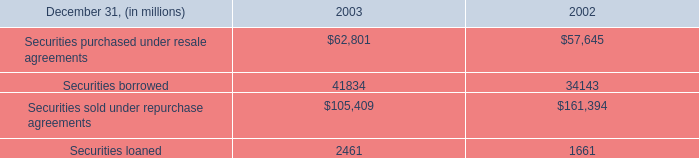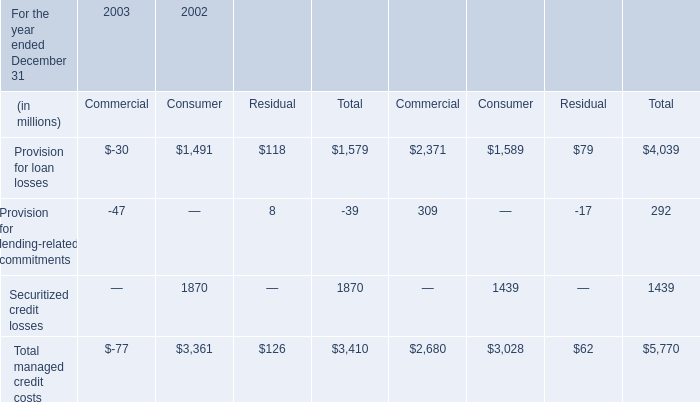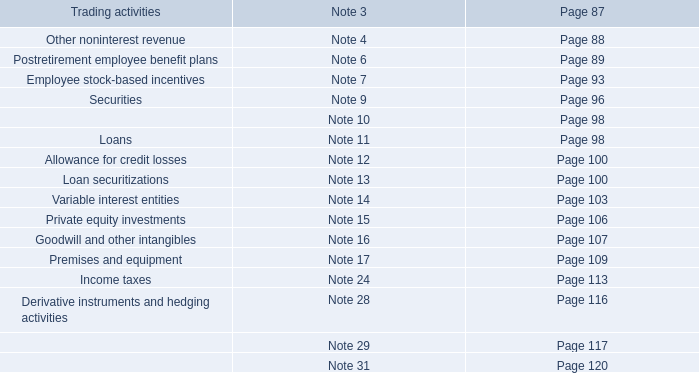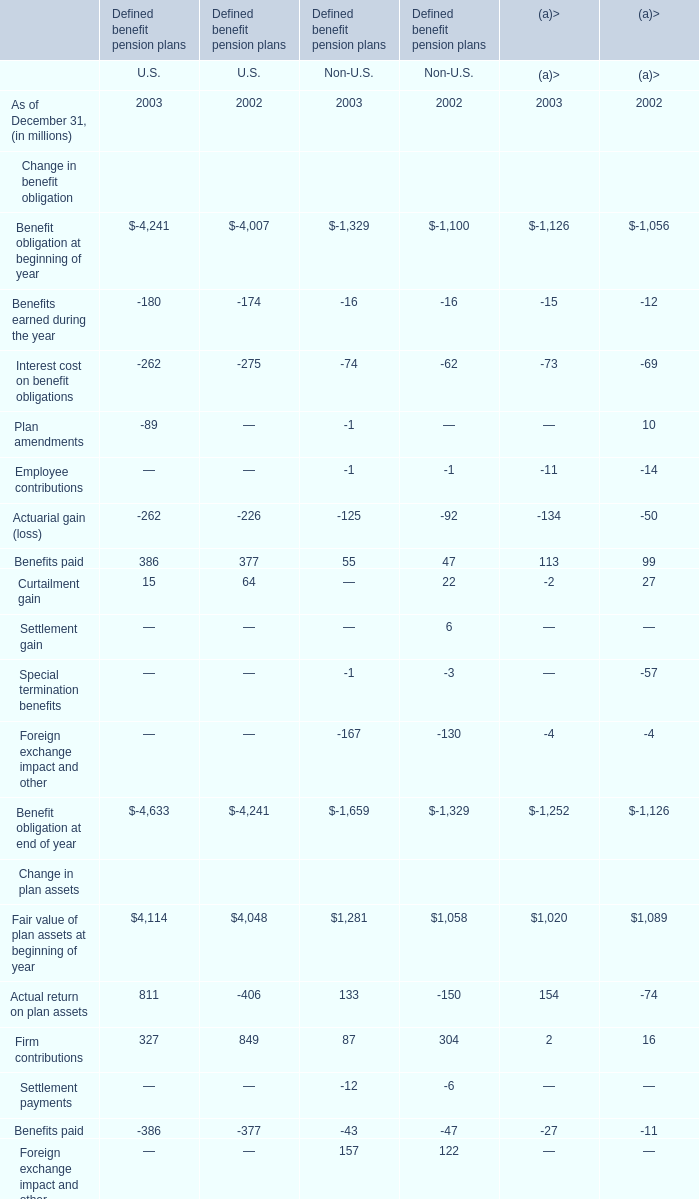What is the sum of Provision for loan losses of 2002 Consumer, and Securities loaned of 2003 ? 
Computations: (1589.0 + 2461.0)
Answer: 4050.0. 